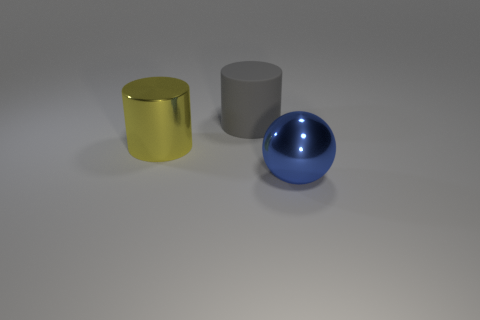What number of other things are there of the same size as the sphere?
Your response must be concise. 2. There is a large shiny cylinder; is it the same color as the large metallic object right of the big gray matte object?
Give a very brief answer. No. How many things are large gray objects or big cylinders?
Your answer should be very brief. 2. Is there anything else that has the same color as the big metal sphere?
Offer a terse response. No. Do the large gray thing and the large thing that is in front of the large metallic cylinder have the same material?
Provide a short and direct response. No. What is the shape of the large metal thing on the left side of the large metal object that is to the right of the yellow cylinder?
Make the answer very short. Cylinder. There is a big object that is both left of the big blue sphere and in front of the rubber cylinder; what is its shape?
Your response must be concise. Cylinder. What number of objects are either shiny objects or large objects in front of the big gray rubber cylinder?
Keep it short and to the point. 2. What material is the gray thing that is the same shape as the yellow metal object?
Ensure brevity in your answer.  Rubber. Is there any other thing that has the same material as the big yellow object?
Give a very brief answer. Yes. 